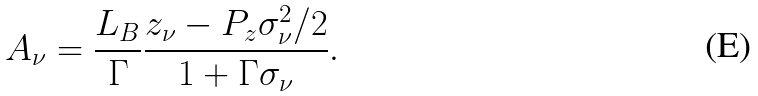Convert formula to latex. <formula><loc_0><loc_0><loc_500><loc_500>A _ { \nu } = \frac { L _ { B } } \Gamma \frac { z _ { \nu } - P _ { z } \sigma _ { \nu } ^ { 2 } / 2 } { 1 + \Gamma \sigma _ { \nu } } .</formula> 